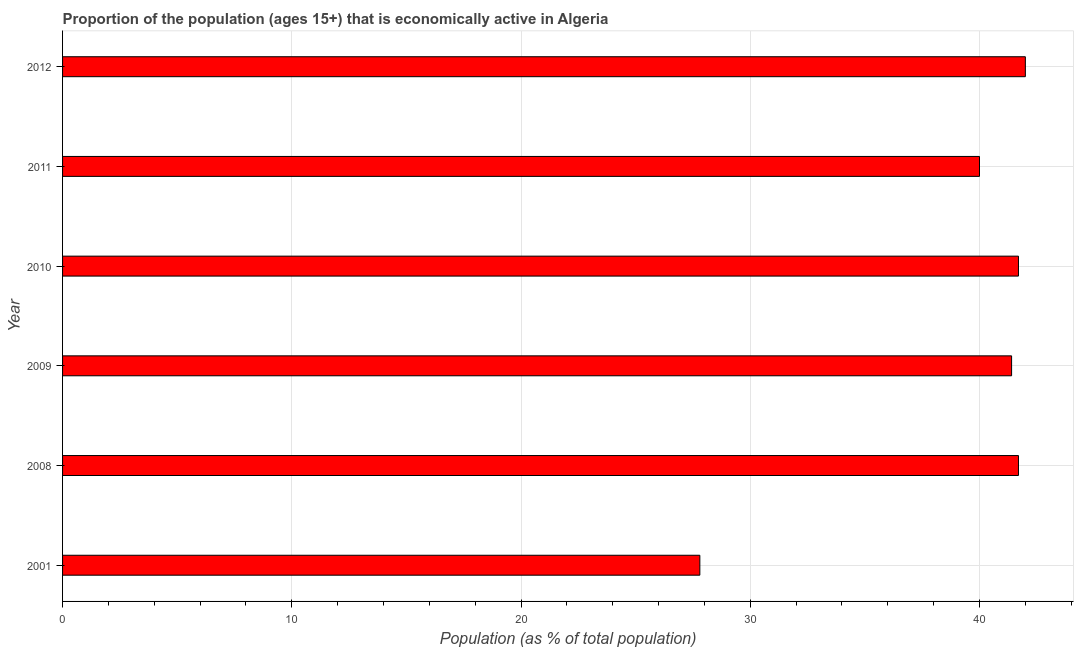What is the title of the graph?
Offer a very short reply. Proportion of the population (ages 15+) that is economically active in Algeria. What is the label or title of the X-axis?
Keep it short and to the point. Population (as % of total population). What is the label or title of the Y-axis?
Offer a terse response. Year. What is the percentage of economically active population in 2010?
Your response must be concise. 41.7. Across all years, what is the minimum percentage of economically active population?
Give a very brief answer. 27.8. In which year was the percentage of economically active population maximum?
Your response must be concise. 2012. In which year was the percentage of economically active population minimum?
Provide a short and direct response. 2001. What is the sum of the percentage of economically active population?
Make the answer very short. 234.6. What is the difference between the percentage of economically active population in 2010 and 2011?
Your answer should be compact. 1.7. What is the average percentage of economically active population per year?
Your answer should be compact. 39.1. What is the median percentage of economically active population?
Your response must be concise. 41.55. In how many years, is the percentage of economically active population greater than 4 %?
Offer a terse response. 6. Is the difference between the percentage of economically active population in 2001 and 2010 greater than the difference between any two years?
Offer a very short reply. No. What is the difference between the highest and the second highest percentage of economically active population?
Your answer should be compact. 0.3. How many bars are there?
Your response must be concise. 6. How many years are there in the graph?
Provide a short and direct response. 6. What is the difference between two consecutive major ticks on the X-axis?
Offer a terse response. 10. Are the values on the major ticks of X-axis written in scientific E-notation?
Provide a succinct answer. No. What is the Population (as % of total population) in 2001?
Provide a short and direct response. 27.8. What is the Population (as % of total population) of 2008?
Ensure brevity in your answer.  41.7. What is the Population (as % of total population) of 2009?
Your answer should be very brief. 41.4. What is the Population (as % of total population) in 2010?
Make the answer very short. 41.7. What is the difference between the Population (as % of total population) in 2001 and 2010?
Keep it short and to the point. -13.9. What is the difference between the Population (as % of total population) in 2008 and 2010?
Your response must be concise. 0. What is the difference between the Population (as % of total population) in 2008 and 2011?
Your answer should be very brief. 1.7. What is the difference between the Population (as % of total population) in 2008 and 2012?
Your answer should be very brief. -0.3. What is the difference between the Population (as % of total population) in 2009 and 2011?
Ensure brevity in your answer.  1.4. What is the difference between the Population (as % of total population) in 2010 and 2011?
Make the answer very short. 1.7. What is the difference between the Population (as % of total population) in 2010 and 2012?
Offer a very short reply. -0.3. What is the ratio of the Population (as % of total population) in 2001 to that in 2008?
Offer a terse response. 0.67. What is the ratio of the Population (as % of total population) in 2001 to that in 2009?
Your response must be concise. 0.67. What is the ratio of the Population (as % of total population) in 2001 to that in 2010?
Provide a succinct answer. 0.67. What is the ratio of the Population (as % of total population) in 2001 to that in 2011?
Give a very brief answer. 0.69. What is the ratio of the Population (as % of total population) in 2001 to that in 2012?
Offer a very short reply. 0.66. What is the ratio of the Population (as % of total population) in 2008 to that in 2011?
Your response must be concise. 1.04. What is the ratio of the Population (as % of total population) in 2008 to that in 2012?
Ensure brevity in your answer.  0.99. What is the ratio of the Population (as % of total population) in 2009 to that in 2011?
Keep it short and to the point. 1.03. What is the ratio of the Population (as % of total population) in 2009 to that in 2012?
Keep it short and to the point. 0.99. What is the ratio of the Population (as % of total population) in 2010 to that in 2011?
Ensure brevity in your answer.  1.04. 